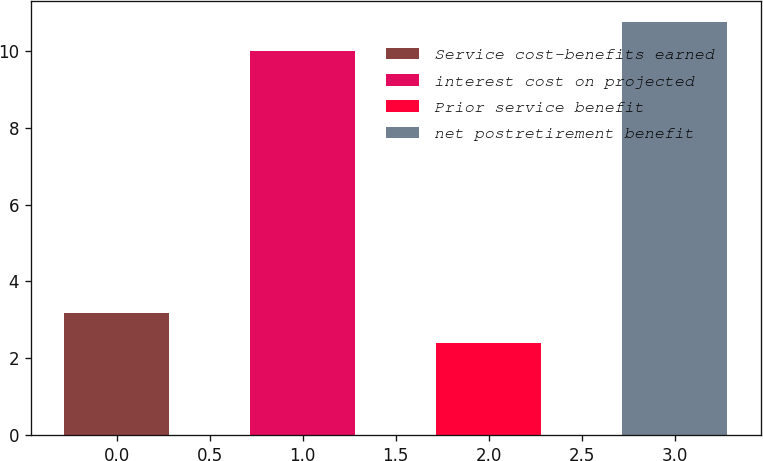<chart> <loc_0><loc_0><loc_500><loc_500><bar_chart><fcel>Service cost-benefits earned<fcel>interest cost on projected<fcel>Prior service benefit<fcel>net postretirement benefit<nl><fcel>3.17<fcel>10<fcel>2.4<fcel>10.77<nl></chart> 